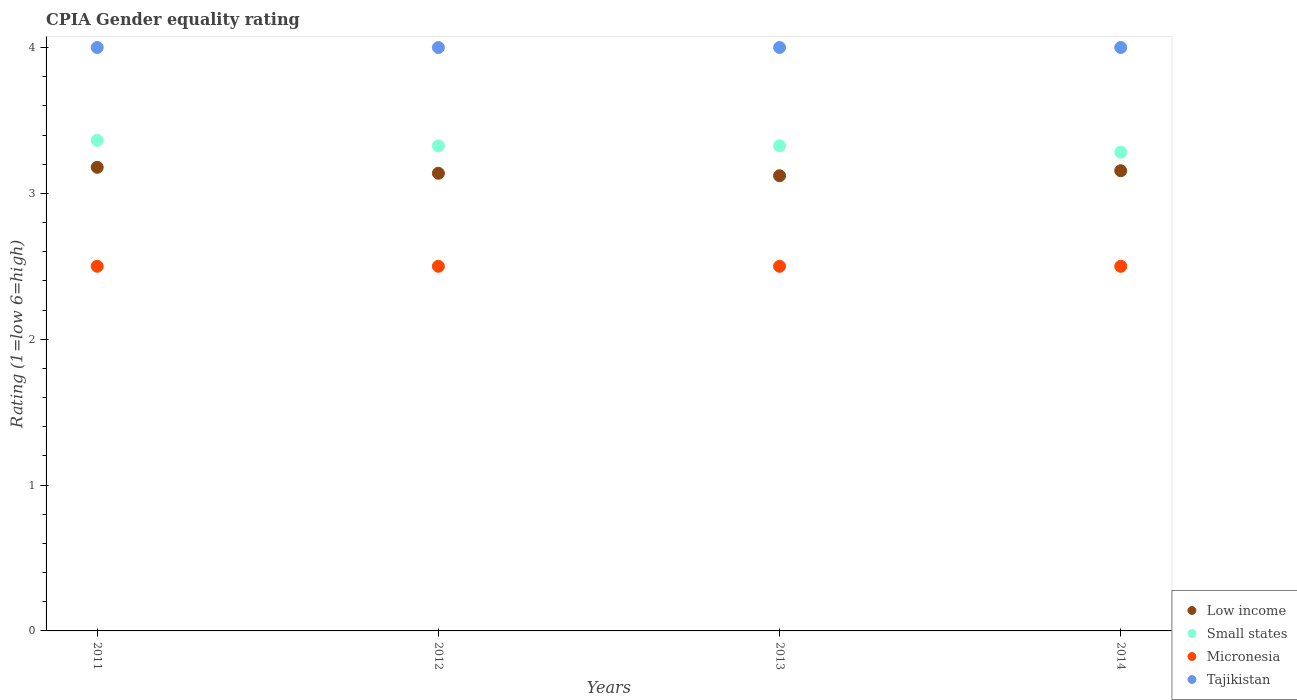How many different coloured dotlines are there?
Your answer should be compact. 4. What is the CPIA rating in Micronesia in 2012?
Your answer should be compact. 2.5. Across all years, what is the maximum CPIA rating in Small states?
Offer a very short reply. 3.36. Across all years, what is the minimum CPIA rating in Tajikistan?
Ensure brevity in your answer.  4. What is the total CPIA rating in Micronesia in the graph?
Give a very brief answer. 10. What is the difference between the CPIA rating in Low income in 2011 and that in 2014?
Offer a very short reply. 0.02. What is the average CPIA rating in Low income per year?
Provide a short and direct response. 3.15. In the year 2014, what is the difference between the CPIA rating in Low income and CPIA rating in Small states?
Provide a succinct answer. -0.13. What is the ratio of the CPIA rating in Small states in 2012 to that in 2014?
Keep it short and to the point. 1.01. What is the difference between the highest and the second highest CPIA rating in Micronesia?
Ensure brevity in your answer.  0. Is the sum of the CPIA rating in Low income in 2012 and 2013 greater than the maximum CPIA rating in Small states across all years?
Offer a very short reply. Yes. Is it the case that in every year, the sum of the CPIA rating in Low income and CPIA rating in Micronesia  is greater than the CPIA rating in Small states?
Keep it short and to the point. Yes. Does the CPIA rating in Tajikistan monotonically increase over the years?
Your response must be concise. No. Is the CPIA rating in Low income strictly greater than the CPIA rating in Micronesia over the years?
Provide a succinct answer. Yes. How many dotlines are there?
Make the answer very short. 4. Does the graph contain any zero values?
Keep it short and to the point. No. What is the title of the graph?
Your answer should be very brief. CPIA Gender equality rating. What is the label or title of the X-axis?
Ensure brevity in your answer.  Years. What is the label or title of the Y-axis?
Your answer should be very brief. Rating (1=low 6=high). What is the Rating (1=low 6=high) of Low income in 2011?
Your answer should be very brief. 3.18. What is the Rating (1=low 6=high) in Small states in 2011?
Your response must be concise. 3.36. What is the Rating (1=low 6=high) of Micronesia in 2011?
Offer a terse response. 2.5. What is the Rating (1=low 6=high) in Tajikistan in 2011?
Make the answer very short. 4. What is the Rating (1=low 6=high) in Low income in 2012?
Offer a terse response. 3.14. What is the Rating (1=low 6=high) of Small states in 2012?
Keep it short and to the point. 3.33. What is the Rating (1=low 6=high) of Micronesia in 2012?
Make the answer very short. 2.5. What is the Rating (1=low 6=high) of Low income in 2013?
Offer a terse response. 3.12. What is the Rating (1=low 6=high) of Small states in 2013?
Your answer should be compact. 3.33. What is the Rating (1=low 6=high) of Tajikistan in 2013?
Offer a terse response. 4. What is the Rating (1=low 6=high) of Low income in 2014?
Your response must be concise. 3.16. What is the Rating (1=low 6=high) in Small states in 2014?
Your response must be concise. 3.28. What is the Rating (1=low 6=high) of Micronesia in 2014?
Make the answer very short. 2.5. Across all years, what is the maximum Rating (1=low 6=high) in Low income?
Your response must be concise. 3.18. Across all years, what is the maximum Rating (1=low 6=high) of Small states?
Offer a very short reply. 3.36. Across all years, what is the maximum Rating (1=low 6=high) of Micronesia?
Offer a very short reply. 2.5. Across all years, what is the maximum Rating (1=low 6=high) in Tajikistan?
Provide a short and direct response. 4. Across all years, what is the minimum Rating (1=low 6=high) of Low income?
Offer a terse response. 3.12. Across all years, what is the minimum Rating (1=low 6=high) of Small states?
Provide a succinct answer. 3.28. Across all years, what is the minimum Rating (1=low 6=high) in Micronesia?
Give a very brief answer. 2.5. What is the total Rating (1=low 6=high) in Low income in the graph?
Your answer should be very brief. 12.59. What is the total Rating (1=low 6=high) of Small states in the graph?
Your answer should be very brief. 13.3. What is the total Rating (1=low 6=high) in Micronesia in the graph?
Ensure brevity in your answer.  10. What is the total Rating (1=low 6=high) of Tajikistan in the graph?
Your answer should be compact. 16. What is the difference between the Rating (1=low 6=high) in Low income in 2011 and that in 2012?
Your answer should be very brief. 0.04. What is the difference between the Rating (1=low 6=high) of Small states in 2011 and that in 2012?
Offer a very short reply. 0.04. What is the difference between the Rating (1=low 6=high) in Micronesia in 2011 and that in 2012?
Your response must be concise. 0. What is the difference between the Rating (1=low 6=high) of Low income in 2011 and that in 2013?
Make the answer very short. 0.06. What is the difference between the Rating (1=low 6=high) of Small states in 2011 and that in 2013?
Make the answer very short. 0.04. What is the difference between the Rating (1=low 6=high) of Low income in 2011 and that in 2014?
Your response must be concise. 0.02. What is the difference between the Rating (1=low 6=high) of Small states in 2011 and that in 2014?
Ensure brevity in your answer.  0.08. What is the difference between the Rating (1=low 6=high) of Low income in 2012 and that in 2013?
Give a very brief answer. 0.02. What is the difference between the Rating (1=low 6=high) in Micronesia in 2012 and that in 2013?
Offer a terse response. 0. What is the difference between the Rating (1=low 6=high) of Low income in 2012 and that in 2014?
Offer a terse response. -0.02. What is the difference between the Rating (1=low 6=high) of Small states in 2012 and that in 2014?
Make the answer very short. 0.04. What is the difference between the Rating (1=low 6=high) in Micronesia in 2012 and that in 2014?
Offer a terse response. 0. What is the difference between the Rating (1=low 6=high) in Low income in 2013 and that in 2014?
Make the answer very short. -0.03. What is the difference between the Rating (1=low 6=high) of Small states in 2013 and that in 2014?
Give a very brief answer. 0.04. What is the difference between the Rating (1=low 6=high) of Micronesia in 2013 and that in 2014?
Offer a very short reply. 0. What is the difference between the Rating (1=low 6=high) of Low income in 2011 and the Rating (1=low 6=high) of Small states in 2012?
Your response must be concise. -0.15. What is the difference between the Rating (1=low 6=high) in Low income in 2011 and the Rating (1=low 6=high) in Micronesia in 2012?
Give a very brief answer. 0.68. What is the difference between the Rating (1=low 6=high) in Low income in 2011 and the Rating (1=low 6=high) in Tajikistan in 2012?
Keep it short and to the point. -0.82. What is the difference between the Rating (1=low 6=high) of Small states in 2011 and the Rating (1=low 6=high) of Micronesia in 2012?
Your response must be concise. 0.86. What is the difference between the Rating (1=low 6=high) of Small states in 2011 and the Rating (1=low 6=high) of Tajikistan in 2012?
Offer a very short reply. -0.64. What is the difference between the Rating (1=low 6=high) of Micronesia in 2011 and the Rating (1=low 6=high) of Tajikistan in 2012?
Give a very brief answer. -1.5. What is the difference between the Rating (1=low 6=high) in Low income in 2011 and the Rating (1=low 6=high) in Small states in 2013?
Keep it short and to the point. -0.15. What is the difference between the Rating (1=low 6=high) of Low income in 2011 and the Rating (1=low 6=high) of Micronesia in 2013?
Provide a succinct answer. 0.68. What is the difference between the Rating (1=low 6=high) in Low income in 2011 and the Rating (1=low 6=high) in Tajikistan in 2013?
Your answer should be very brief. -0.82. What is the difference between the Rating (1=low 6=high) of Small states in 2011 and the Rating (1=low 6=high) of Micronesia in 2013?
Offer a terse response. 0.86. What is the difference between the Rating (1=low 6=high) in Small states in 2011 and the Rating (1=low 6=high) in Tajikistan in 2013?
Ensure brevity in your answer.  -0.64. What is the difference between the Rating (1=low 6=high) of Low income in 2011 and the Rating (1=low 6=high) of Small states in 2014?
Give a very brief answer. -0.1. What is the difference between the Rating (1=low 6=high) in Low income in 2011 and the Rating (1=low 6=high) in Micronesia in 2014?
Your answer should be very brief. 0.68. What is the difference between the Rating (1=low 6=high) of Low income in 2011 and the Rating (1=low 6=high) of Tajikistan in 2014?
Provide a succinct answer. -0.82. What is the difference between the Rating (1=low 6=high) in Small states in 2011 and the Rating (1=low 6=high) in Micronesia in 2014?
Provide a short and direct response. 0.86. What is the difference between the Rating (1=low 6=high) in Small states in 2011 and the Rating (1=low 6=high) in Tajikistan in 2014?
Your answer should be very brief. -0.64. What is the difference between the Rating (1=low 6=high) in Low income in 2012 and the Rating (1=low 6=high) in Small states in 2013?
Your answer should be compact. -0.19. What is the difference between the Rating (1=low 6=high) of Low income in 2012 and the Rating (1=low 6=high) of Micronesia in 2013?
Your response must be concise. 0.64. What is the difference between the Rating (1=low 6=high) in Low income in 2012 and the Rating (1=low 6=high) in Tajikistan in 2013?
Keep it short and to the point. -0.86. What is the difference between the Rating (1=low 6=high) in Small states in 2012 and the Rating (1=low 6=high) in Micronesia in 2013?
Give a very brief answer. 0.83. What is the difference between the Rating (1=low 6=high) of Small states in 2012 and the Rating (1=low 6=high) of Tajikistan in 2013?
Offer a very short reply. -0.67. What is the difference between the Rating (1=low 6=high) of Low income in 2012 and the Rating (1=low 6=high) of Small states in 2014?
Provide a short and direct response. -0.14. What is the difference between the Rating (1=low 6=high) of Low income in 2012 and the Rating (1=low 6=high) of Micronesia in 2014?
Offer a terse response. 0.64. What is the difference between the Rating (1=low 6=high) of Low income in 2012 and the Rating (1=low 6=high) of Tajikistan in 2014?
Make the answer very short. -0.86. What is the difference between the Rating (1=low 6=high) of Small states in 2012 and the Rating (1=low 6=high) of Micronesia in 2014?
Offer a very short reply. 0.83. What is the difference between the Rating (1=low 6=high) in Small states in 2012 and the Rating (1=low 6=high) in Tajikistan in 2014?
Keep it short and to the point. -0.67. What is the difference between the Rating (1=low 6=high) of Low income in 2013 and the Rating (1=low 6=high) of Small states in 2014?
Make the answer very short. -0.16. What is the difference between the Rating (1=low 6=high) in Low income in 2013 and the Rating (1=low 6=high) in Micronesia in 2014?
Provide a succinct answer. 0.62. What is the difference between the Rating (1=low 6=high) of Low income in 2013 and the Rating (1=low 6=high) of Tajikistan in 2014?
Provide a short and direct response. -0.88. What is the difference between the Rating (1=low 6=high) in Small states in 2013 and the Rating (1=low 6=high) in Micronesia in 2014?
Your answer should be very brief. 0.83. What is the difference between the Rating (1=low 6=high) in Small states in 2013 and the Rating (1=low 6=high) in Tajikistan in 2014?
Provide a short and direct response. -0.67. What is the difference between the Rating (1=low 6=high) of Micronesia in 2013 and the Rating (1=low 6=high) of Tajikistan in 2014?
Make the answer very short. -1.5. What is the average Rating (1=low 6=high) in Low income per year?
Your answer should be very brief. 3.15. What is the average Rating (1=low 6=high) in Small states per year?
Give a very brief answer. 3.32. In the year 2011, what is the difference between the Rating (1=low 6=high) of Low income and Rating (1=low 6=high) of Small states?
Your answer should be compact. -0.19. In the year 2011, what is the difference between the Rating (1=low 6=high) in Low income and Rating (1=low 6=high) in Micronesia?
Offer a terse response. 0.68. In the year 2011, what is the difference between the Rating (1=low 6=high) of Low income and Rating (1=low 6=high) of Tajikistan?
Provide a succinct answer. -0.82. In the year 2011, what is the difference between the Rating (1=low 6=high) in Small states and Rating (1=low 6=high) in Micronesia?
Offer a terse response. 0.86. In the year 2011, what is the difference between the Rating (1=low 6=high) in Small states and Rating (1=low 6=high) in Tajikistan?
Your answer should be compact. -0.64. In the year 2011, what is the difference between the Rating (1=low 6=high) of Micronesia and Rating (1=low 6=high) of Tajikistan?
Give a very brief answer. -1.5. In the year 2012, what is the difference between the Rating (1=low 6=high) in Low income and Rating (1=low 6=high) in Small states?
Keep it short and to the point. -0.19. In the year 2012, what is the difference between the Rating (1=low 6=high) in Low income and Rating (1=low 6=high) in Micronesia?
Your answer should be compact. 0.64. In the year 2012, what is the difference between the Rating (1=low 6=high) of Low income and Rating (1=low 6=high) of Tajikistan?
Your answer should be very brief. -0.86. In the year 2012, what is the difference between the Rating (1=low 6=high) of Small states and Rating (1=low 6=high) of Micronesia?
Keep it short and to the point. 0.83. In the year 2012, what is the difference between the Rating (1=low 6=high) in Small states and Rating (1=low 6=high) in Tajikistan?
Your answer should be compact. -0.67. In the year 2013, what is the difference between the Rating (1=low 6=high) of Low income and Rating (1=low 6=high) of Small states?
Offer a terse response. -0.21. In the year 2013, what is the difference between the Rating (1=low 6=high) of Low income and Rating (1=low 6=high) of Micronesia?
Your answer should be compact. 0.62. In the year 2013, what is the difference between the Rating (1=low 6=high) in Low income and Rating (1=low 6=high) in Tajikistan?
Make the answer very short. -0.88. In the year 2013, what is the difference between the Rating (1=low 6=high) in Small states and Rating (1=low 6=high) in Micronesia?
Offer a terse response. 0.83. In the year 2013, what is the difference between the Rating (1=low 6=high) of Small states and Rating (1=low 6=high) of Tajikistan?
Your answer should be very brief. -0.67. In the year 2013, what is the difference between the Rating (1=low 6=high) in Micronesia and Rating (1=low 6=high) in Tajikistan?
Provide a short and direct response. -1.5. In the year 2014, what is the difference between the Rating (1=low 6=high) of Low income and Rating (1=low 6=high) of Small states?
Provide a succinct answer. -0.13. In the year 2014, what is the difference between the Rating (1=low 6=high) of Low income and Rating (1=low 6=high) of Micronesia?
Make the answer very short. 0.66. In the year 2014, what is the difference between the Rating (1=low 6=high) in Low income and Rating (1=low 6=high) in Tajikistan?
Offer a very short reply. -0.84. In the year 2014, what is the difference between the Rating (1=low 6=high) in Small states and Rating (1=low 6=high) in Micronesia?
Give a very brief answer. 0.78. In the year 2014, what is the difference between the Rating (1=low 6=high) of Small states and Rating (1=low 6=high) of Tajikistan?
Provide a short and direct response. -0.72. In the year 2014, what is the difference between the Rating (1=low 6=high) of Micronesia and Rating (1=low 6=high) of Tajikistan?
Your answer should be compact. -1.5. What is the ratio of the Rating (1=low 6=high) of Small states in 2011 to that in 2012?
Offer a terse response. 1.01. What is the ratio of the Rating (1=low 6=high) in Micronesia in 2011 to that in 2012?
Ensure brevity in your answer.  1. What is the ratio of the Rating (1=low 6=high) of Low income in 2011 to that in 2013?
Provide a succinct answer. 1.02. What is the ratio of the Rating (1=low 6=high) of Small states in 2011 to that in 2013?
Offer a terse response. 1.01. What is the ratio of the Rating (1=low 6=high) in Micronesia in 2011 to that in 2013?
Keep it short and to the point. 1. What is the ratio of the Rating (1=low 6=high) in Low income in 2011 to that in 2014?
Provide a succinct answer. 1.01. What is the ratio of the Rating (1=low 6=high) of Small states in 2011 to that in 2014?
Offer a terse response. 1.02. What is the ratio of the Rating (1=low 6=high) of Micronesia in 2011 to that in 2014?
Offer a terse response. 1. What is the ratio of the Rating (1=low 6=high) in Tajikistan in 2011 to that in 2014?
Your response must be concise. 1. What is the ratio of the Rating (1=low 6=high) in Low income in 2012 to that in 2013?
Your response must be concise. 1.01. What is the ratio of the Rating (1=low 6=high) of Micronesia in 2012 to that in 2013?
Your answer should be very brief. 1. What is the ratio of the Rating (1=low 6=high) in Low income in 2012 to that in 2014?
Offer a very short reply. 0.99. What is the ratio of the Rating (1=low 6=high) in Small states in 2012 to that in 2014?
Provide a short and direct response. 1.01. What is the ratio of the Rating (1=low 6=high) in Micronesia in 2012 to that in 2014?
Offer a terse response. 1. What is the ratio of the Rating (1=low 6=high) in Low income in 2013 to that in 2014?
Provide a short and direct response. 0.99. What is the ratio of the Rating (1=low 6=high) in Small states in 2013 to that in 2014?
Make the answer very short. 1.01. What is the ratio of the Rating (1=low 6=high) of Micronesia in 2013 to that in 2014?
Ensure brevity in your answer.  1. What is the ratio of the Rating (1=low 6=high) of Tajikistan in 2013 to that in 2014?
Offer a very short reply. 1. What is the difference between the highest and the second highest Rating (1=low 6=high) in Low income?
Ensure brevity in your answer.  0.02. What is the difference between the highest and the second highest Rating (1=low 6=high) in Small states?
Keep it short and to the point. 0.04. What is the difference between the highest and the second highest Rating (1=low 6=high) of Tajikistan?
Your response must be concise. 0. What is the difference between the highest and the lowest Rating (1=low 6=high) in Low income?
Offer a terse response. 0.06. What is the difference between the highest and the lowest Rating (1=low 6=high) in Small states?
Your answer should be compact. 0.08. What is the difference between the highest and the lowest Rating (1=low 6=high) in Micronesia?
Ensure brevity in your answer.  0. What is the difference between the highest and the lowest Rating (1=low 6=high) in Tajikistan?
Make the answer very short. 0. 